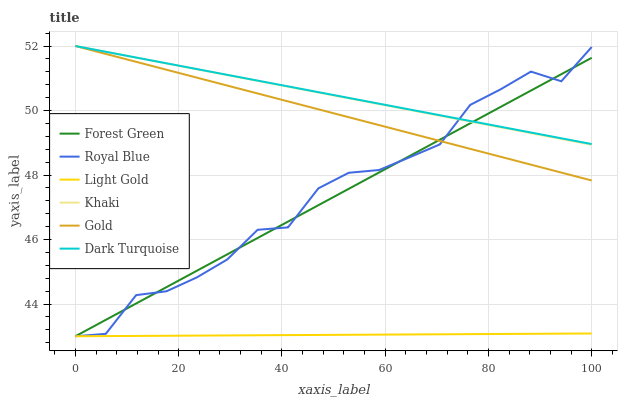Does Light Gold have the minimum area under the curve?
Answer yes or no. Yes. Does Dark Turquoise have the maximum area under the curve?
Answer yes or no. Yes. Does Gold have the minimum area under the curve?
Answer yes or no. No. Does Gold have the maximum area under the curve?
Answer yes or no. No. Is Light Gold the smoothest?
Answer yes or no. Yes. Is Royal Blue the roughest?
Answer yes or no. Yes. Is Gold the smoothest?
Answer yes or no. No. Is Gold the roughest?
Answer yes or no. No. Does Royal Blue have the lowest value?
Answer yes or no. Yes. Does Gold have the lowest value?
Answer yes or no. No. Does Dark Turquoise have the highest value?
Answer yes or no. Yes. Does Royal Blue have the highest value?
Answer yes or no. No. Is Light Gold less than Dark Turquoise?
Answer yes or no. Yes. Is Khaki greater than Light Gold?
Answer yes or no. Yes. Does Forest Green intersect Gold?
Answer yes or no. Yes. Is Forest Green less than Gold?
Answer yes or no. No. Is Forest Green greater than Gold?
Answer yes or no. No. Does Light Gold intersect Dark Turquoise?
Answer yes or no. No. 